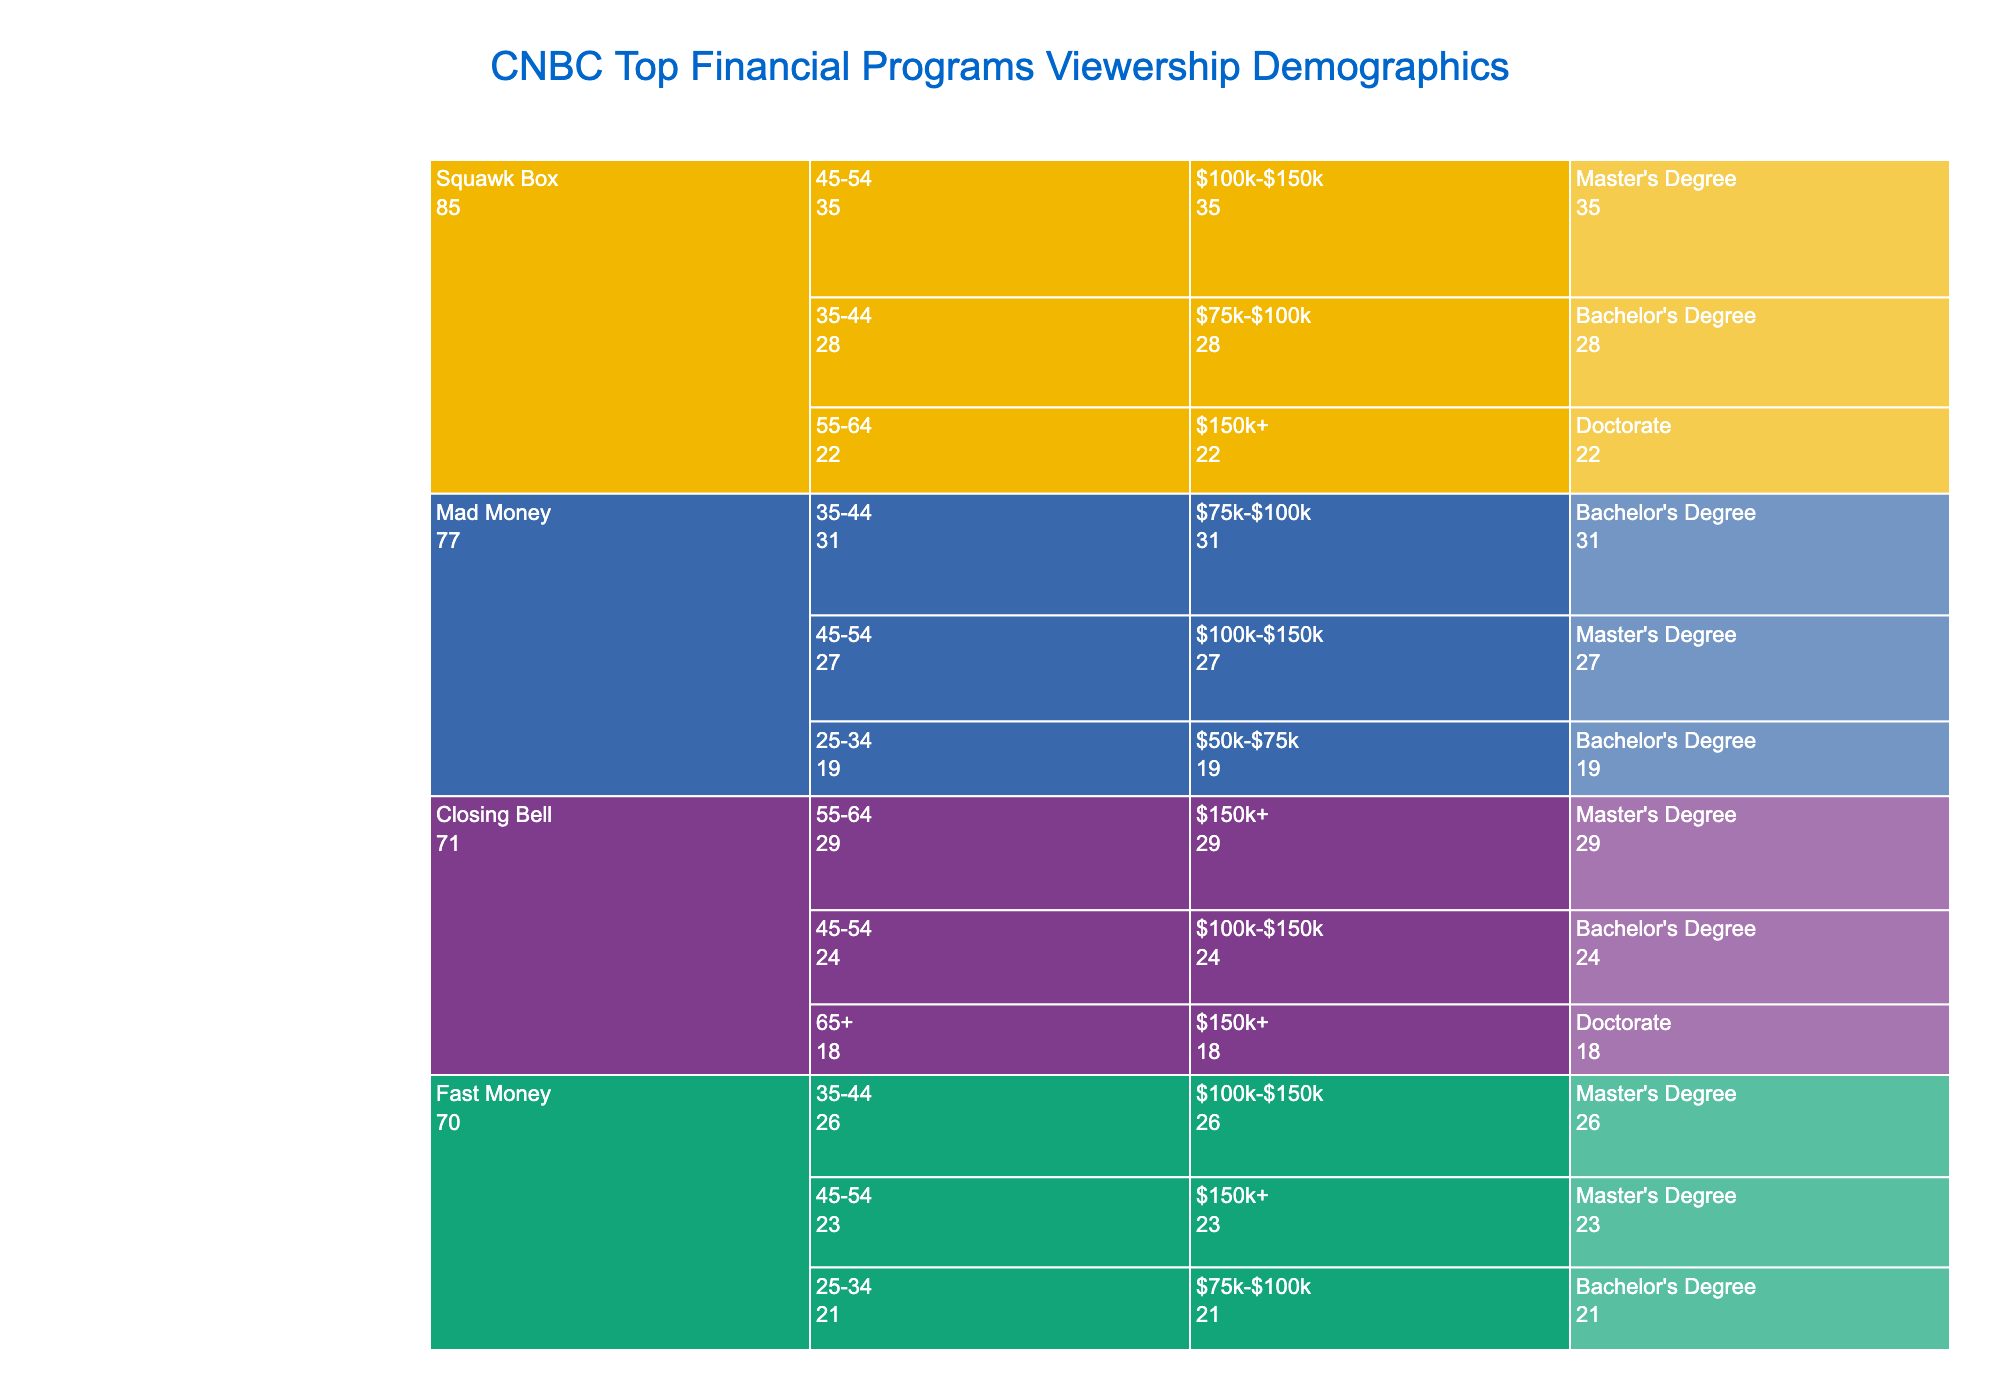What is the total viewership for Squawk Box? Add the viewership numbers for Squawk Box across all categories: 28 + 35 + 22 = 85
Answer: 85 Which program has the highest number of viewers in the age group 45-54? Check the viewership for age group 45-54 across all programs: Squawk Box (35), Mad Money (27), and Closing Bell (24). The highest is Squawk Box with 35 viewers.
Answer: Squawk Box What is the combined viewership for Mad Money in the income groups $50k-$75k and $75k-$100k? Add the viewership numbers for Mad Money in those income groups: 19 (for $50k-$75k) + 31 (for $75k-$100k) = 50
Answer: 50 Which program has the least viewership for the income level $150k+? Look at the viewership for the $150k+ income level: Squawk Box (22), Closing Bell (18), and Fast Money (23). The least is Closing Bell with 18 viewers.
Answer: Closing Bell How many viewers does Fast Money have in the Bachelor's Degree segment? Sum the viewership for Fast Money under Bachelor's Degree: 21 (for 25-34 age group and $75k-$100k) = 21
Answer: 21 What is the total viewership for Closing Bell for all age groups combined? Add the viewership numbers for Closing Bell across all age groups: 24 + 29 + 18 = 71
Answer: 71 How does the viewership for Mad Money with a Master's Degree compare to that of Fast Money with the same degree? Compare Master’s Degree viewership for both programs: Mad Money (27) vs. Fast Money (26). Mad Money has more viewers by 1.
Answer: Mad Money has 1 more Which program targets the Doctorate holders among the 55-64 age group with the highest viewership? Squawk Box is the only program with Doctorate holders in the 55-64 age group with 22 viewers.
Answer: Squawk Box What percentage of Squawk Box’s total viewership comes from those with a Master's Degree? Master’s Degree viewership for Squawk Box is 35. Total Squawk Box viewership is 85. So, (35 / 85) * 100% = 41.18%
Answer: 41.18% What is the viewership distribution between Bachelor's and Master's Degree holders for Fast Money? Bachelor's Degree holders for Fast Money are 21 and Master's Degree holders are 49 (26+23).
Answer: Bachelor's: 21, Master's: 49 